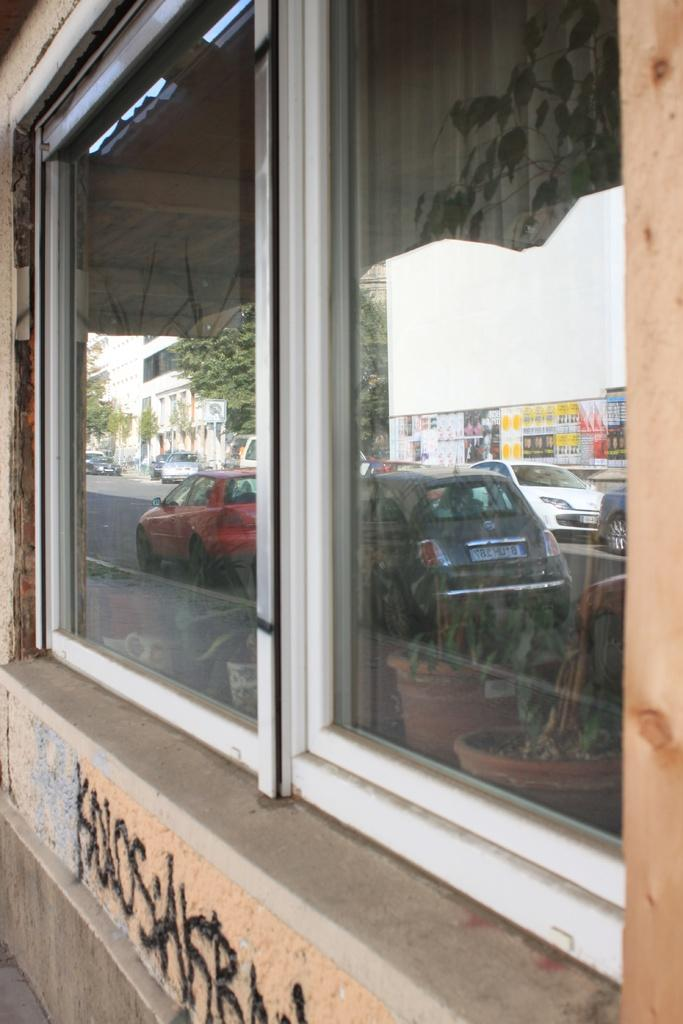What type of structure is present in the image? There is a glass window and a wall in the image. What can be seen in the reflection of the glass window? The glass window has reflections of plants with pots, vehicles on the road, buildings, a board, and trees. What type of stove is visible in the image? There is no stove present in the image. The image primarily features a glass window with various reflections and a wall. 